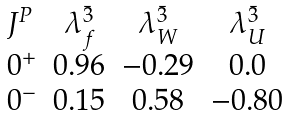Convert formula to latex. <formula><loc_0><loc_0><loc_500><loc_500>\begin{array} { l c c c } J ^ { P } & \lambda _ { f } ^ { \bar { 3 } } & \lambda _ { W } ^ { \bar { 3 } } & \lambda _ { U } ^ { \bar { 3 } } \\ 0 ^ { + } & 0 . 9 6 & - 0 . 2 9 & 0 . 0 \\ 0 ^ { - } & 0 . 1 5 & 0 . 5 8 & - 0 . 8 0 \end{array}</formula> 